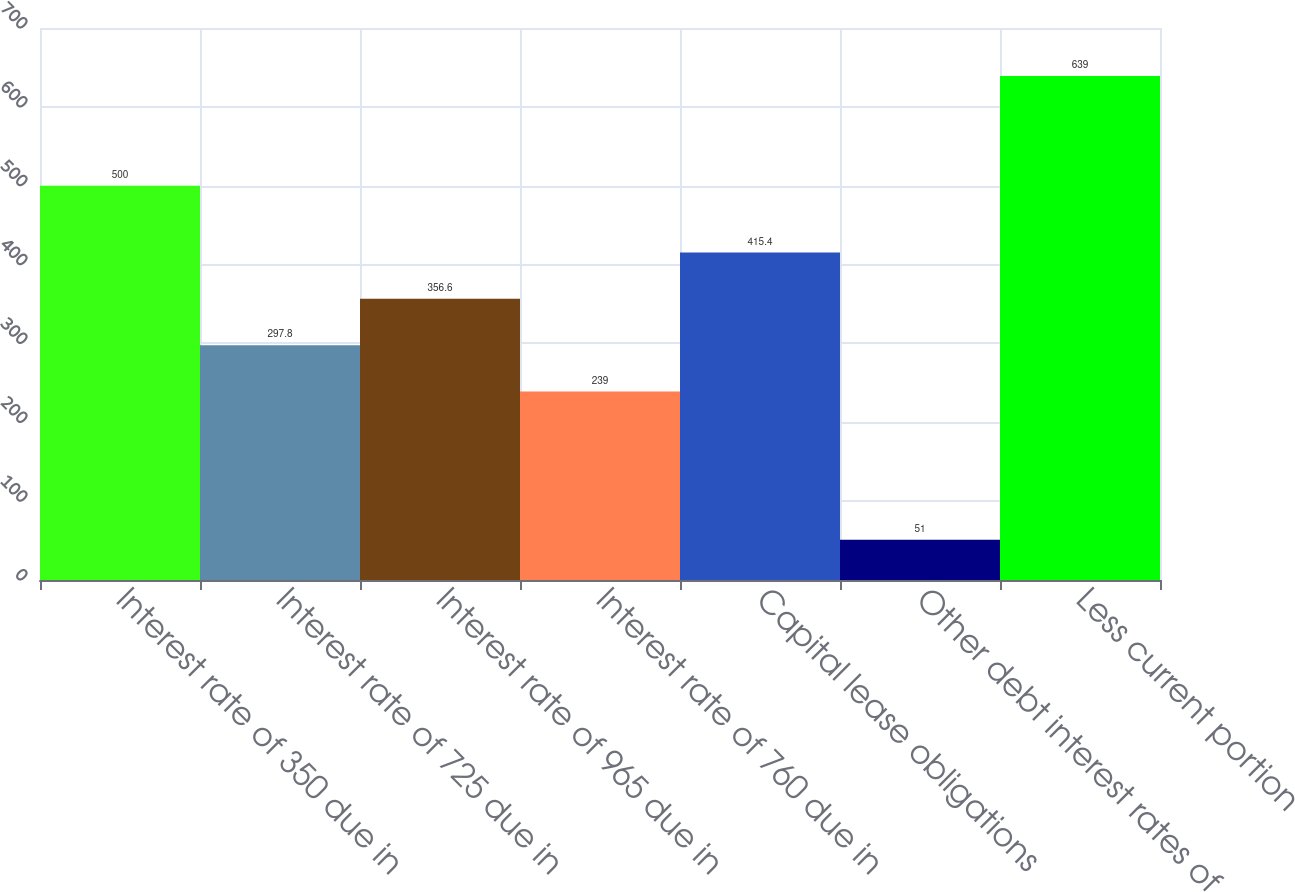<chart> <loc_0><loc_0><loc_500><loc_500><bar_chart><fcel>Interest rate of 350 due in<fcel>Interest rate of 725 due in<fcel>Interest rate of 965 due in<fcel>Interest rate of 760 due in<fcel>Capital lease obligations<fcel>Other debt interest rates of<fcel>Less current portion<nl><fcel>500<fcel>297.8<fcel>356.6<fcel>239<fcel>415.4<fcel>51<fcel>639<nl></chart> 